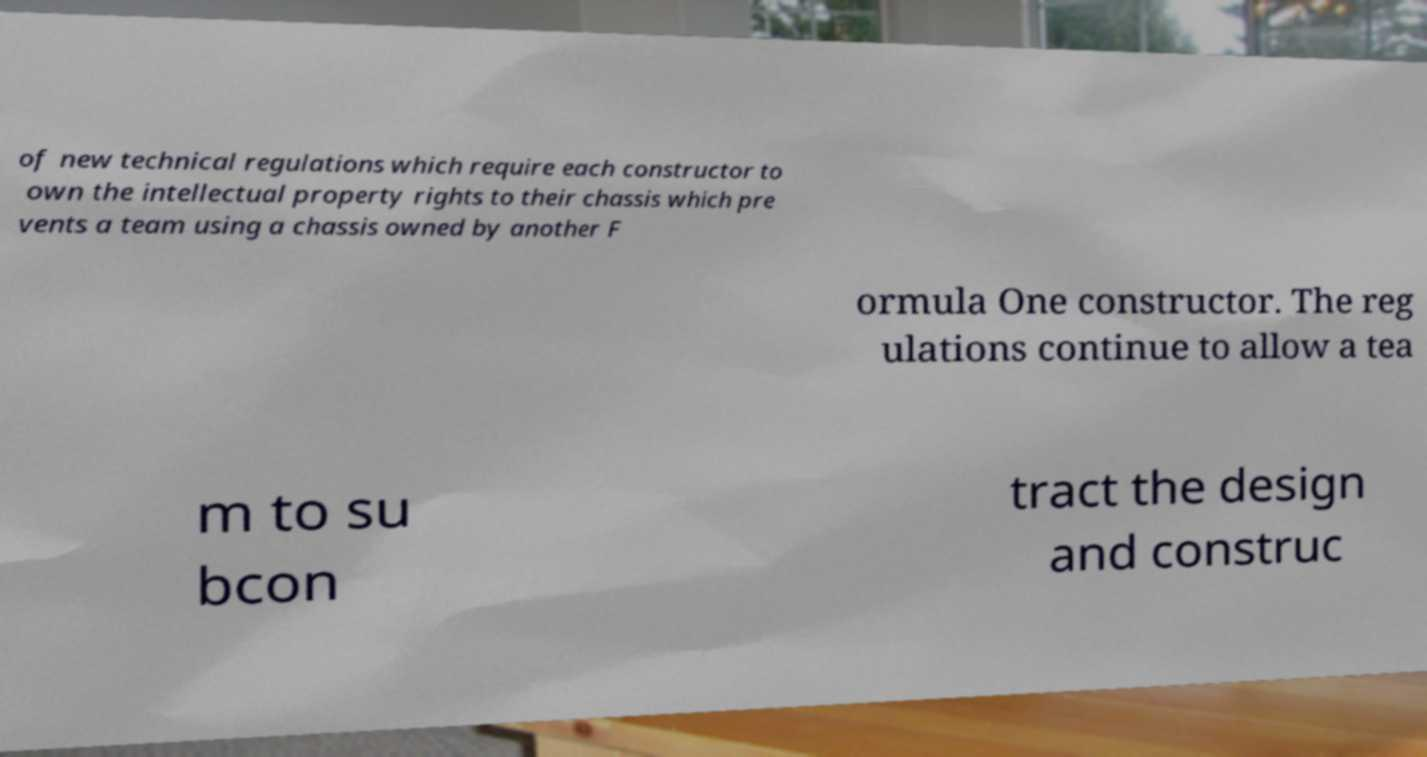There's text embedded in this image that I need extracted. Can you transcribe it verbatim? of new technical regulations which require each constructor to own the intellectual property rights to their chassis which pre vents a team using a chassis owned by another F ormula One constructor. The reg ulations continue to allow a tea m to su bcon tract the design and construc 